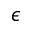<formula> <loc_0><loc_0><loc_500><loc_500>\epsilon</formula> 